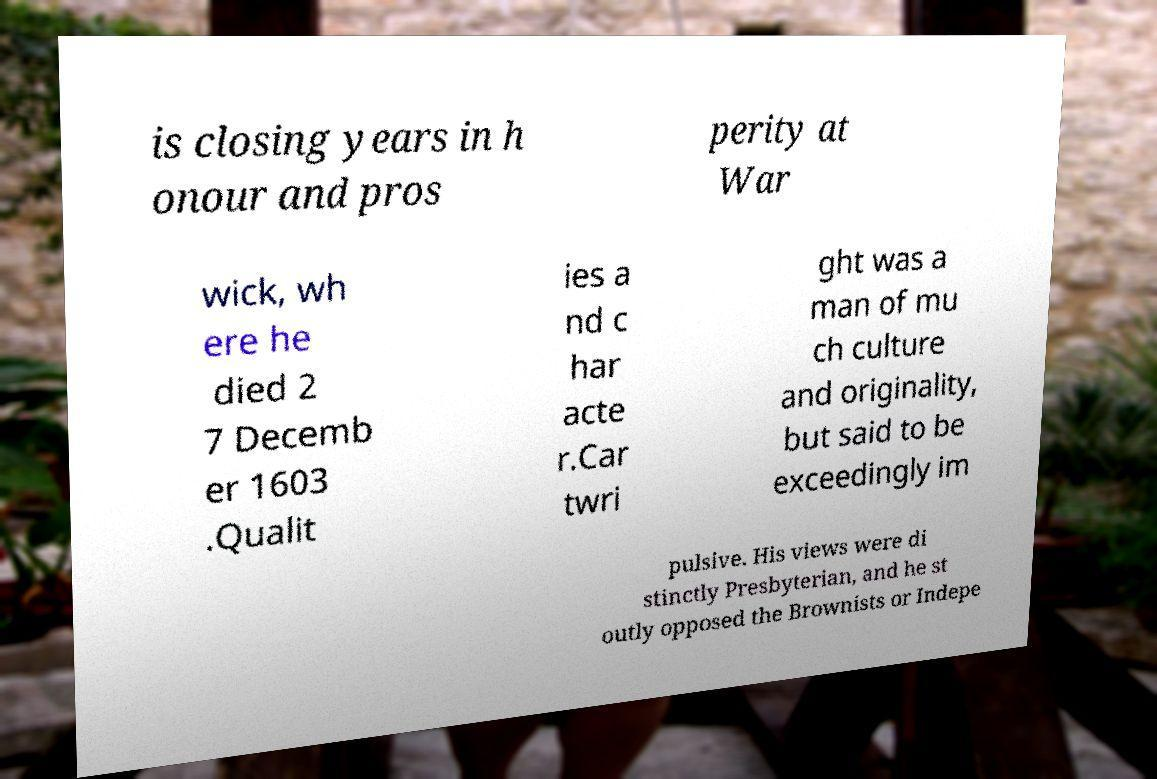Could you extract and type out the text from this image? is closing years in h onour and pros perity at War wick, wh ere he died 2 7 Decemb er 1603 .Qualit ies a nd c har acte r.Car twri ght was a man of mu ch culture and originality, but said to be exceedingly im pulsive. His views were di stinctly Presbyterian, and he st outly opposed the Brownists or Indepe 